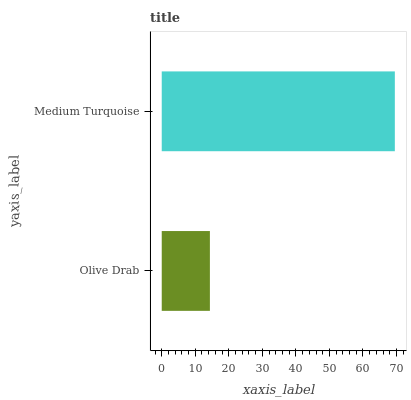Is Olive Drab the minimum?
Answer yes or no. Yes. Is Medium Turquoise the maximum?
Answer yes or no. Yes. Is Medium Turquoise the minimum?
Answer yes or no. No. Is Medium Turquoise greater than Olive Drab?
Answer yes or no. Yes. Is Olive Drab less than Medium Turquoise?
Answer yes or no. Yes. Is Olive Drab greater than Medium Turquoise?
Answer yes or no. No. Is Medium Turquoise less than Olive Drab?
Answer yes or no. No. Is Medium Turquoise the high median?
Answer yes or no. Yes. Is Olive Drab the low median?
Answer yes or no. Yes. Is Olive Drab the high median?
Answer yes or no. No. Is Medium Turquoise the low median?
Answer yes or no. No. 